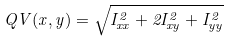<formula> <loc_0><loc_0><loc_500><loc_500>Q V ( x , y ) = \sqrt { I _ { x x } ^ { 2 } + 2 I _ { x y } ^ { 2 } + I _ { y y } ^ { 2 } }</formula> 